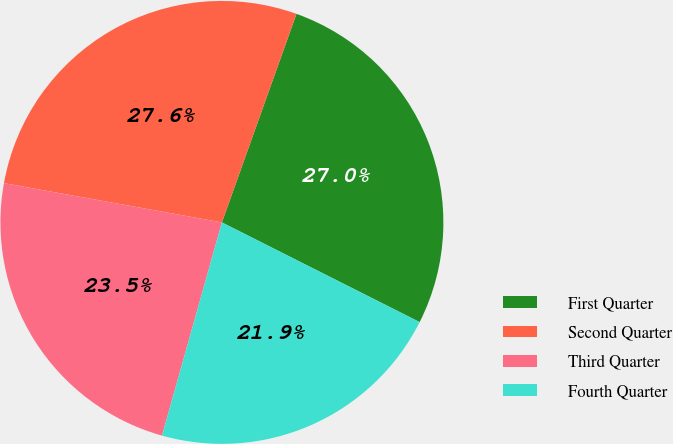<chart> <loc_0><loc_0><loc_500><loc_500><pie_chart><fcel>First Quarter<fcel>Second Quarter<fcel>Third Quarter<fcel>Fourth Quarter<nl><fcel>26.97%<fcel>27.63%<fcel>23.48%<fcel>21.93%<nl></chart> 